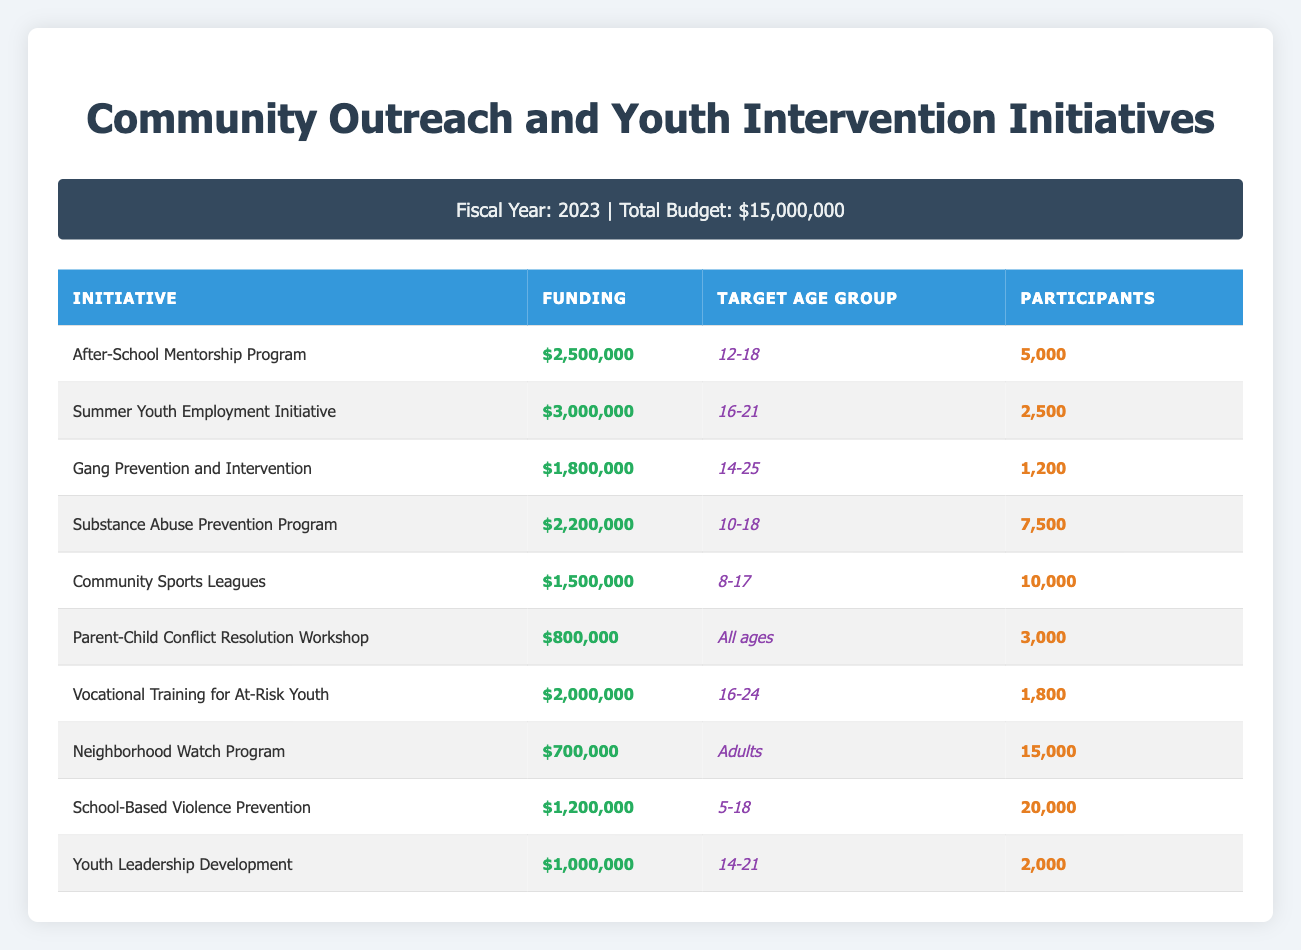What is the funding amount for the After-School Mentorship Program? The funding amount is listed in the table under the "Funding" column next to the After-School Mentorship Program. It states $2,500,000.
Answer: $2,500,000 Which initiative has the highest number of participants? To find the initiative with the highest number of participants, I compare the "Participants" column for all initiatives. The School-Based Violence Prevention has 20,000 participants, which is the highest.
Answer: School-Based Violence Prevention How much total funding is allocated for initiatives targeting ages 10-18? I sum the funding amounts for the initiatives targeting the age group 10-18: Substance Abuse Prevention Program ($2,200,000) and After-School Mentorship Program ($2,500,000). The total is $2,200,000 + $2,500,000 = $4,700,000.
Answer: $4,700,000 Is there an initiative specifically for the age group of 5-18? I check the "Target Age Group" column for any initiative that covers the 5-18 age range. The School-Based Violence Prevention initiative is indeed targeted towards this group.
Answer: Yes What is the average funding per initiative for all funded programs? To calculate the average funding, I sum the funding amounts for all initiatives and divide by the number of initiatives. Total funding is $15,000,000 and there are 10 initiatives, so the average is $15,000,000 / 10 = $1,500,000.
Answer: $1,500,000 How much more funding is allocated to the Summer Youth Employment Initiative compared to the Neighborhood Watch Program? I find the funding for both programs and subtract: Summer Youth Employment Initiative is $3,000,000 and Neighborhood Watch Program is $700,000. Therefore, $3,000,000 - $700,000 = $2,300,000 more for the Summer Youth Employment Initiative.
Answer: $2,300,000 What percentage of the total budget is allocated to the Gang Prevention and Intervention initiative? I take the funding for the Gang Prevention and Intervention initiative, which is $1,800,000, and divide it by the total budget of $15,000,000. Then, I multiply by 100 to get a percentage: ($1,800,000 / $15,000,000) * 100 = 12%.
Answer: 12% Does the Parent-Child Conflict Resolution Workshop have the lowest funding among the initiatives? I compare the funding amounts and see that the Parent-Child Conflict Resolution Workshop has $800,000, which is less than the funding amounts of other initiatives, confirming it has the lowest funding.
Answer: Yes What is the total number of participants across all initiatives targeting youth aged 8-17? I add the participants for the Community Sports Leagues (10,000) and School-Based Violence Prevention (20,000), as both target this age range. Total participants are 10,000 + 20,000 = 30,000.
Answer: 30,000 